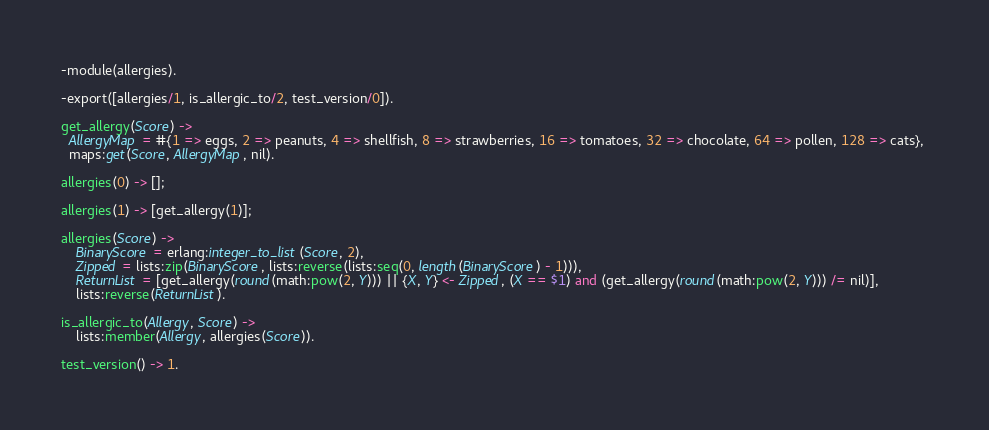Convert code to text. <code><loc_0><loc_0><loc_500><loc_500><_Erlang_>-module(allergies).

-export([allergies/1, is_allergic_to/2, test_version/0]).

get_allergy(Score) ->
  AllergyMap = #{1 => eggs, 2 => peanuts, 4 => shellfish, 8 => strawberries, 16 => tomatoes, 32 => chocolate, 64 => pollen, 128 => cats}, 
  maps:get(Score, AllergyMap, nil).

allergies(0) -> [];

allergies(1) -> [get_allergy(1)];

allergies(Score) ->
	BinaryScore = erlang:integer_to_list(Score, 2),
	Zipped = lists:zip(BinaryScore, lists:reverse(lists:seq(0, length(BinaryScore) - 1))),
	ReturnList = [get_allergy(round(math:pow(2, Y))) || {X, Y} <- Zipped, (X == $1) and (get_allergy(round(math:pow(2, Y))) /= nil)], 
	lists:reverse(ReturnList).

is_allergic_to(Allergy, Score) ->
	lists:member(Allergy, allergies(Score)).

test_version() -> 1.
</code> 